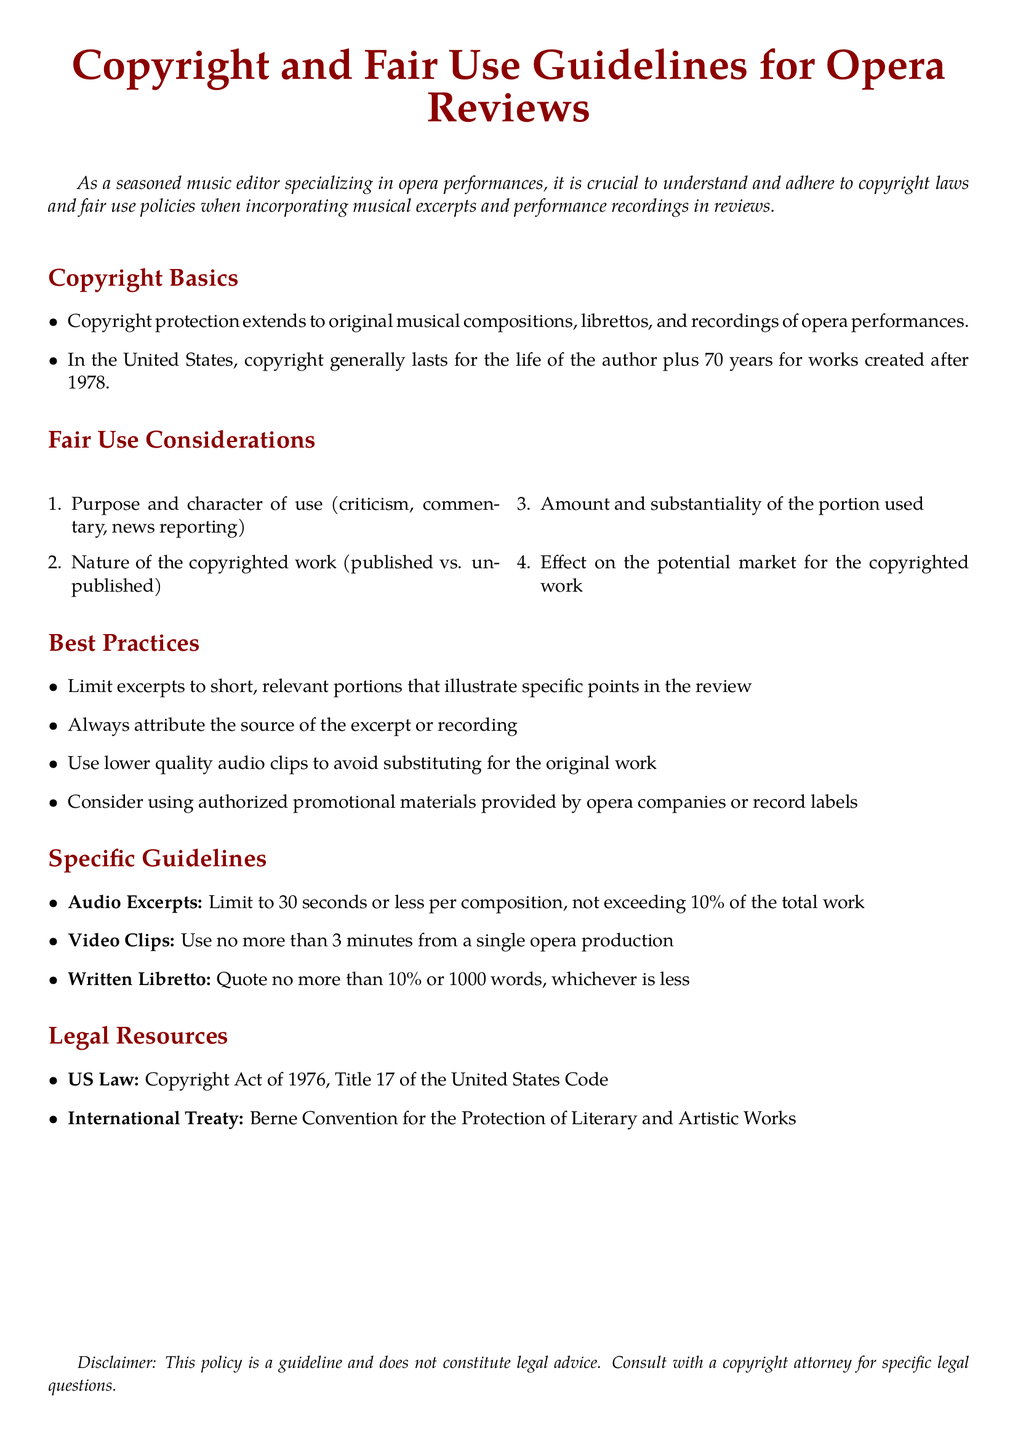What does copyright protection extend to? Copyright protection extends to original musical compositions, librettos, and recordings of opera performances.
Answer: original musical compositions, librettos, and recordings What is the general duration of copyright in the United States? According to the document, copyright generally lasts for the life of the author plus 70 years for works created after 1978.
Answer: life of the author plus 70 years What are the four fair use considerations listed? The document lists purpose and character of use, nature of the copyrighted work, amount and substantiality of the portion used, and effect on the potential market for the copyrighted work.
Answer: Purpose, nature, amount, effect What is the maximum length for audio excerpts? The specific guideline states to limit audio excerpts to 30 seconds or less per composition.
Answer: 30 seconds What percentage of the total work can be used for audio excerpts? The document specifies that audio excerpts should not exceed 10% of the total work.
Answer: 10% What is the maximum length for video clips from a single opera production? The guideline states to use no more than 3 minutes from a single opera production.
Answer: 3 minutes What does the disclaimer indicate about the policy? The disclaimer states that the policy is a guideline and does not constitute legal advice.
Answer: does not constitute legal advice What act governs copyright law in the United States? The document refers to the Copyright Act of 1976, Title 17 of the United States Code.
Answer: Copyright Act of 1976 Which international treaty is referenced in the document? The document mentions the Berne Convention for the Protection of Literary and Artistic Works.
Answer: Berne Convention 